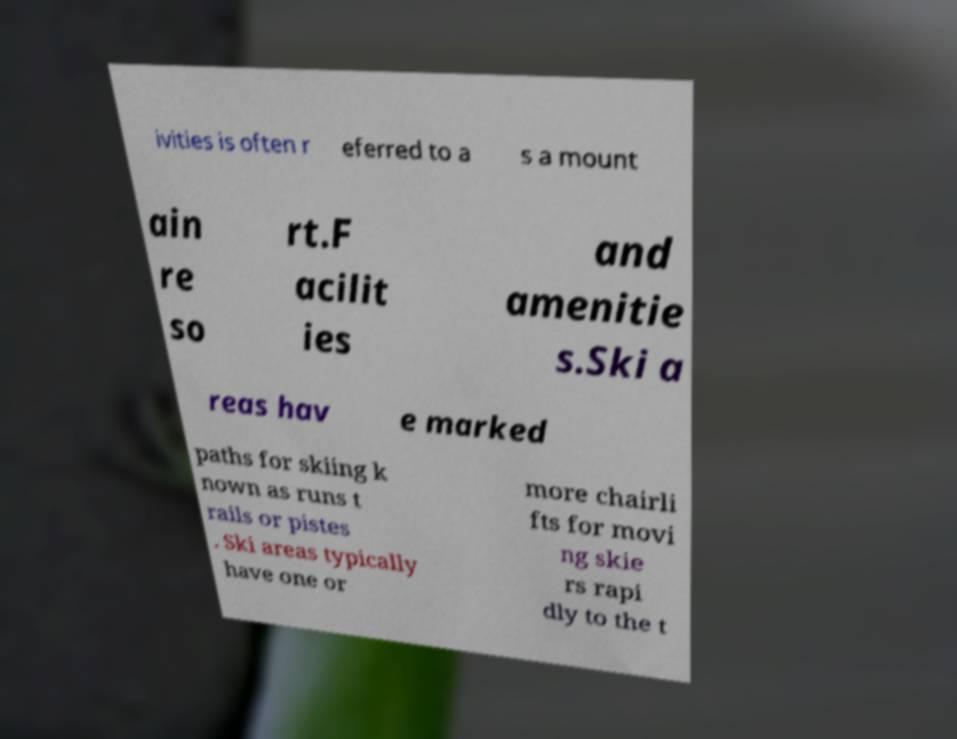Please read and relay the text visible in this image. What does it say? ivities is often r eferred to a s a mount ain re so rt.F acilit ies and amenitie s.Ski a reas hav e marked paths for skiing k nown as runs t rails or pistes . Ski areas typically have one or more chairli fts for movi ng skie rs rapi dly to the t 